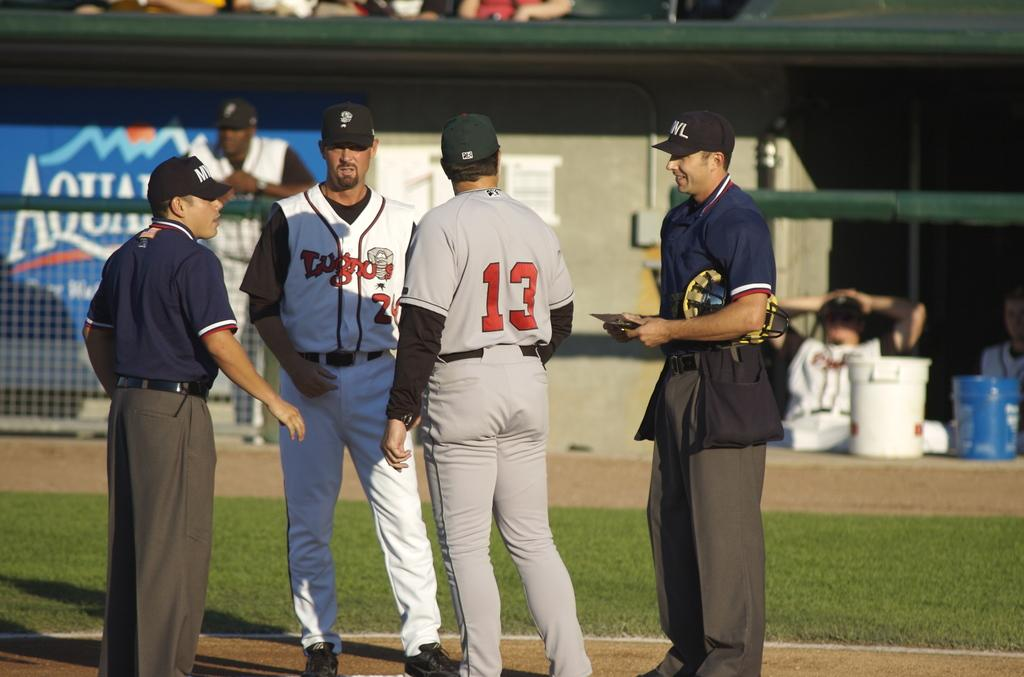<image>
Summarize the visual content of the image. The baseball player number 13 is talking with another player and two officials in front of an Aquafina Sign. 